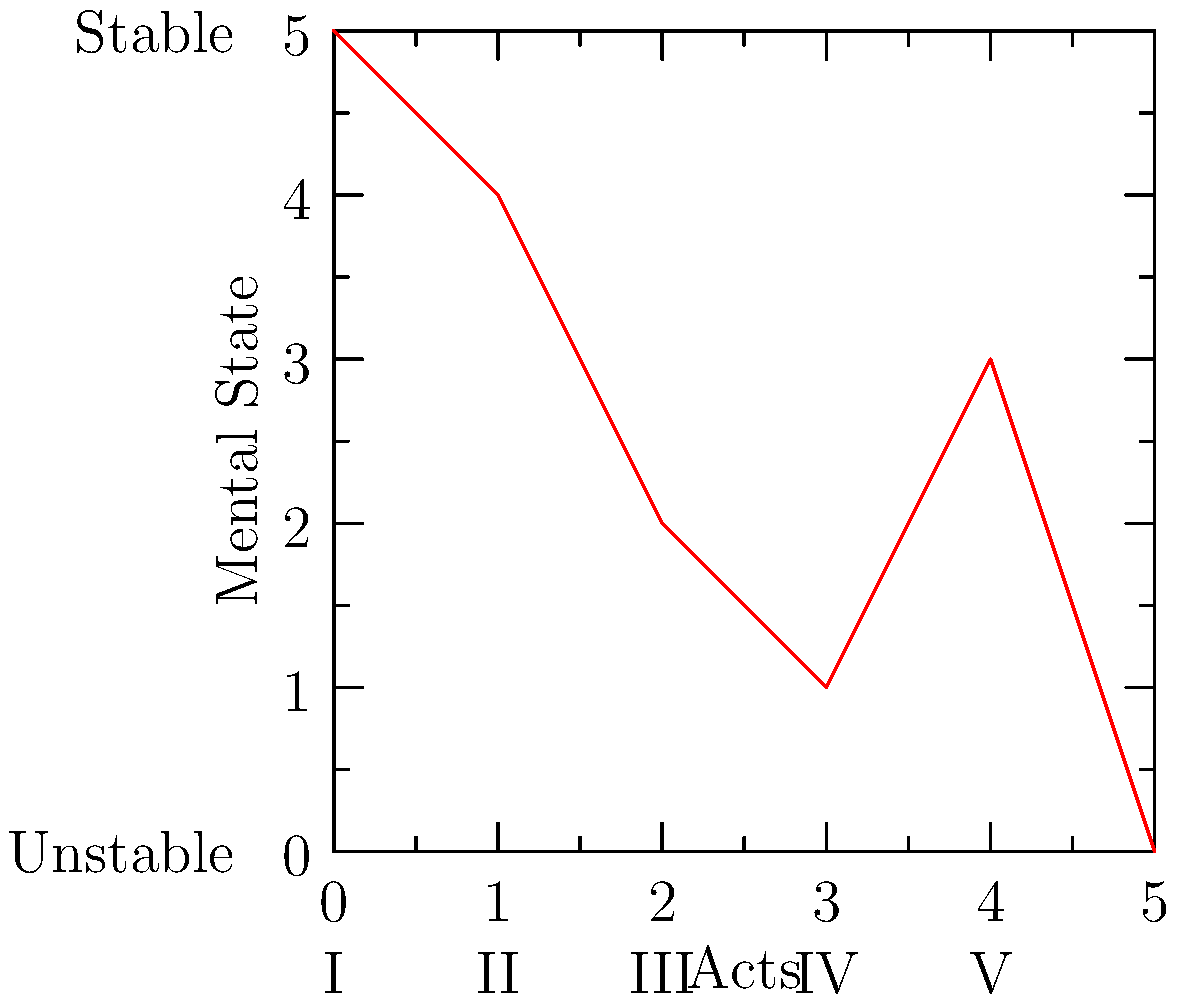Analyze the line graph depicting Macbeth's mental state throughout the play. At which point does Macbeth's mental state reach its lowest, and what significant event in the play might this correspond to? To answer this question, we need to examine the line graph carefully and correlate it with our knowledge of Macbeth's journey in the play:

1. The x-axis represents the five acts of the play, while the y-axis represents Macbeth's mental state from unstable (0) to stable (5).

2. Tracing the line from left to right:
   - Act I: Macbeth starts relatively stable (5)
   - Act II: His mental state declines (4)
   - Act III: It continues to decrease (2)
   - Act IV: We see the lowest point on the graph (1)
   - Act V: There's a slight increase (3) before a final plummet (0)

3. The lowest point occurs during Act IV, reaching a value of 1 on the mental state scale.

4. In Act IV of Macbeth, several significant events occur:
   - Macbeth visits the witches again and receives new prophecies
   - He orders the murder of Macduff's family
   - He learns that Macduff has fled to England to join forces with Malcolm

5. Among these events, the murder of Macduff's innocent family is often considered Macbeth's moral nadir, representing his deepest descent into tyranny and madness.

Therefore, the lowest point on the graph likely corresponds to Macbeth's decision to slaughter Macduff's family, an act of senseless cruelty that marks the height of his paranoia and the depth of his moral degradation.
Answer: Act IV; murder of Macduff's family 